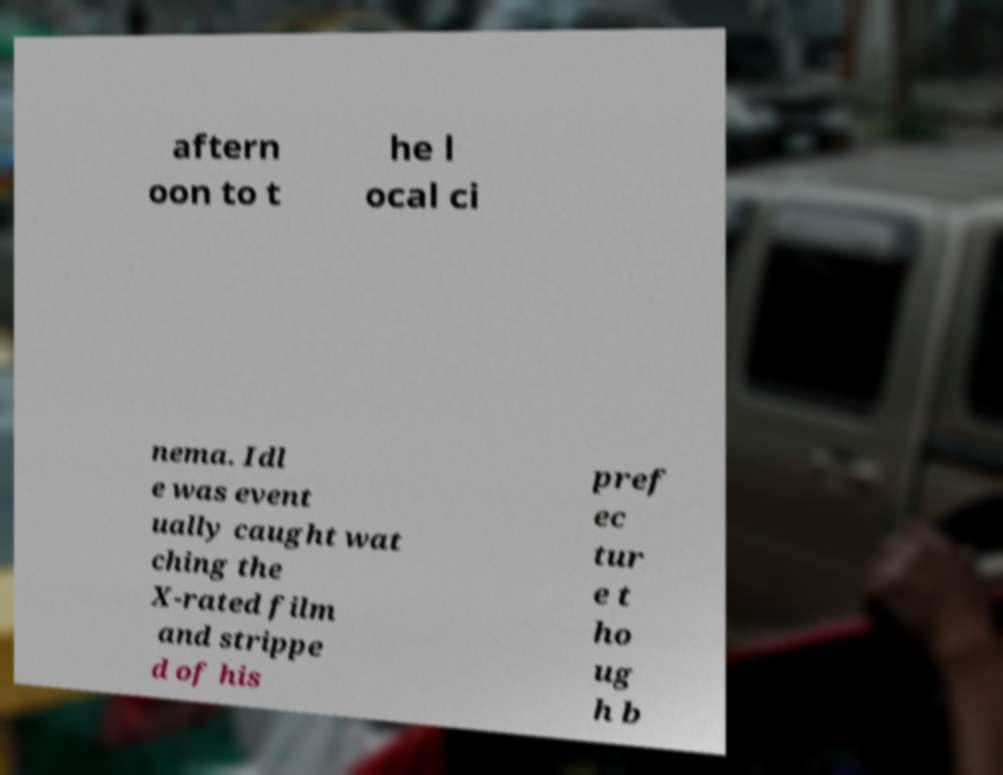Can you accurately transcribe the text from the provided image for me? aftern oon to t he l ocal ci nema. Idl e was event ually caught wat ching the X-rated film and strippe d of his pref ec tur e t ho ug h b 